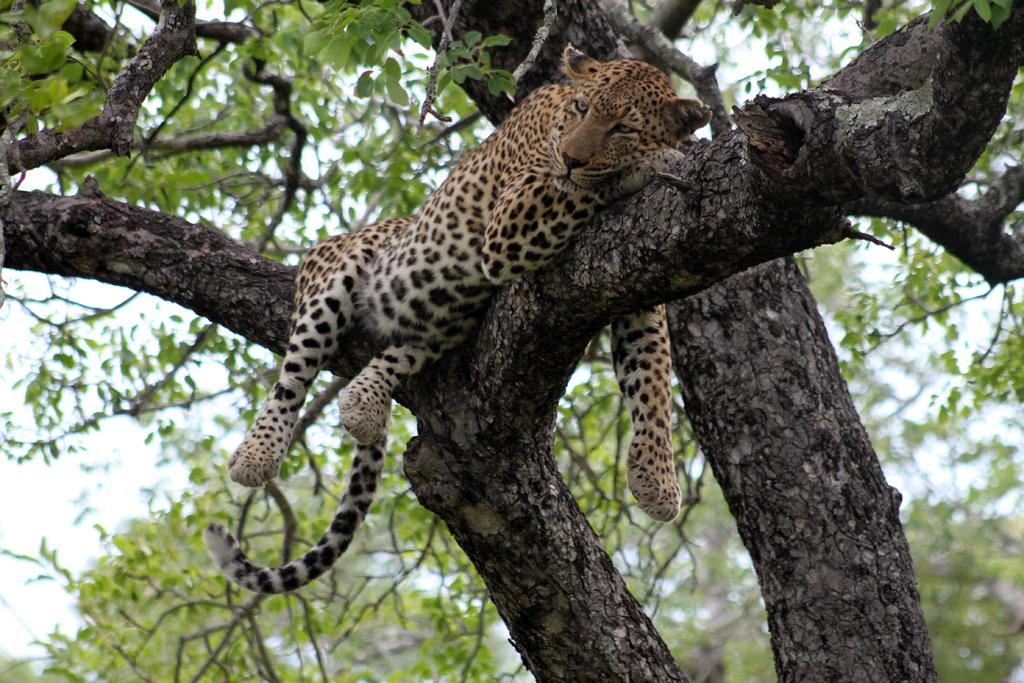What animal is the main subject of the image? There is a cheetah in the image. Where is the cheetah located in the image? The cheetah is on a branch of a tree. What else can be seen in the image besides the cheetah? There are branches of trees and the sky visible in the background of the image. What type of umbrella is the cheetah holding in the image? There is no umbrella present in the image; the cheetah is on a branch of a tree. Is the image depicting a night scene? No, the sky visible in the background of the image suggests it is daytime, not night. 